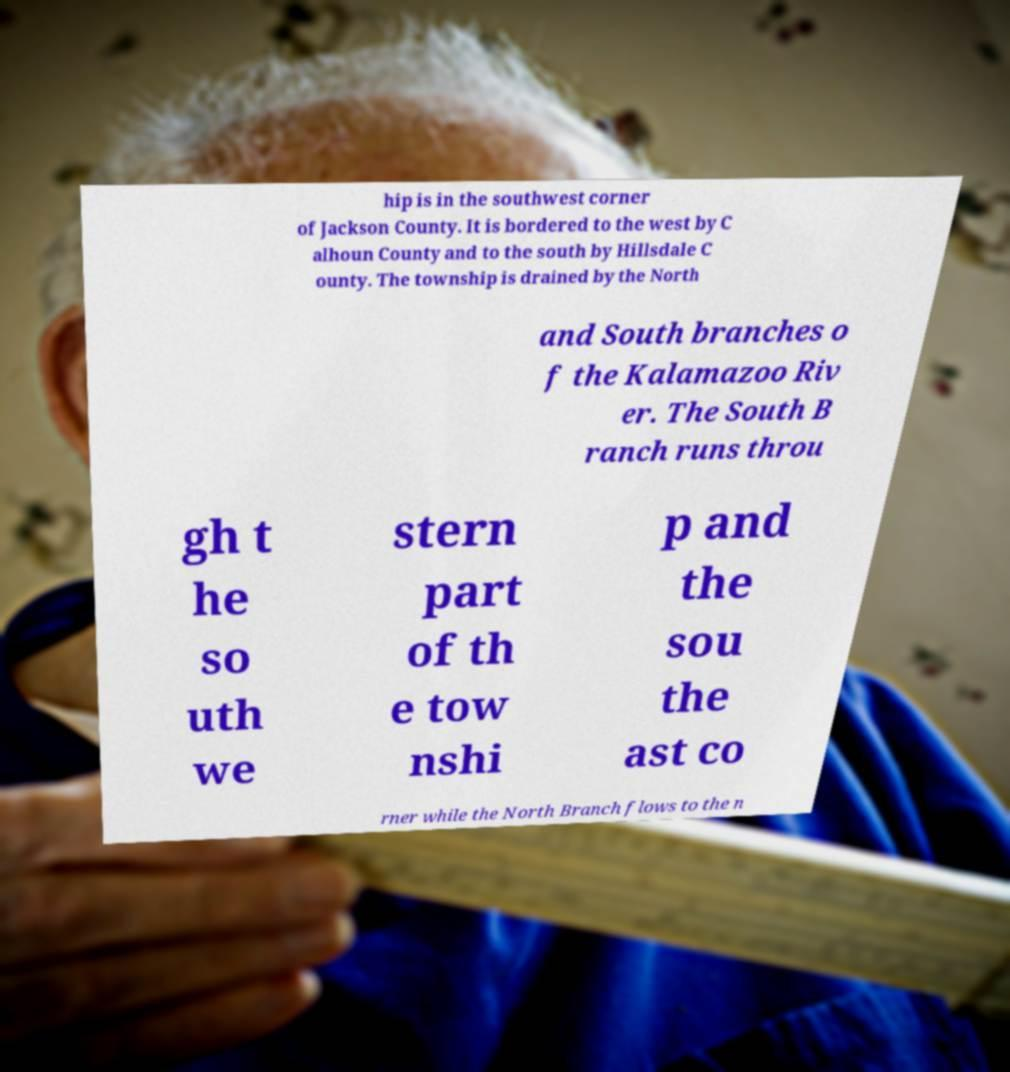Please read and relay the text visible in this image. What does it say? hip is in the southwest corner of Jackson County. It is bordered to the west by C alhoun County and to the south by Hillsdale C ounty. The township is drained by the North and South branches o f the Kalamazoo Riv er. The South B ranch runs throu gh t he so uth we stern part of th e tow nshi p and the sou the ast co rner while the North Branch flows to the n 